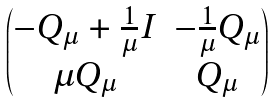Convert formula to latex. <formula><loc_0><loc_0><loc_500><loc_500>\begin{pmatrix} - Q _ { \mu } + \frac { 1 } { \mu } I & - \frac { 1 } { \mu } Q _ { \mu } \\ \mu Q _ { \mu } & Q _ { \mu } \end{pmatrix}</formula> 